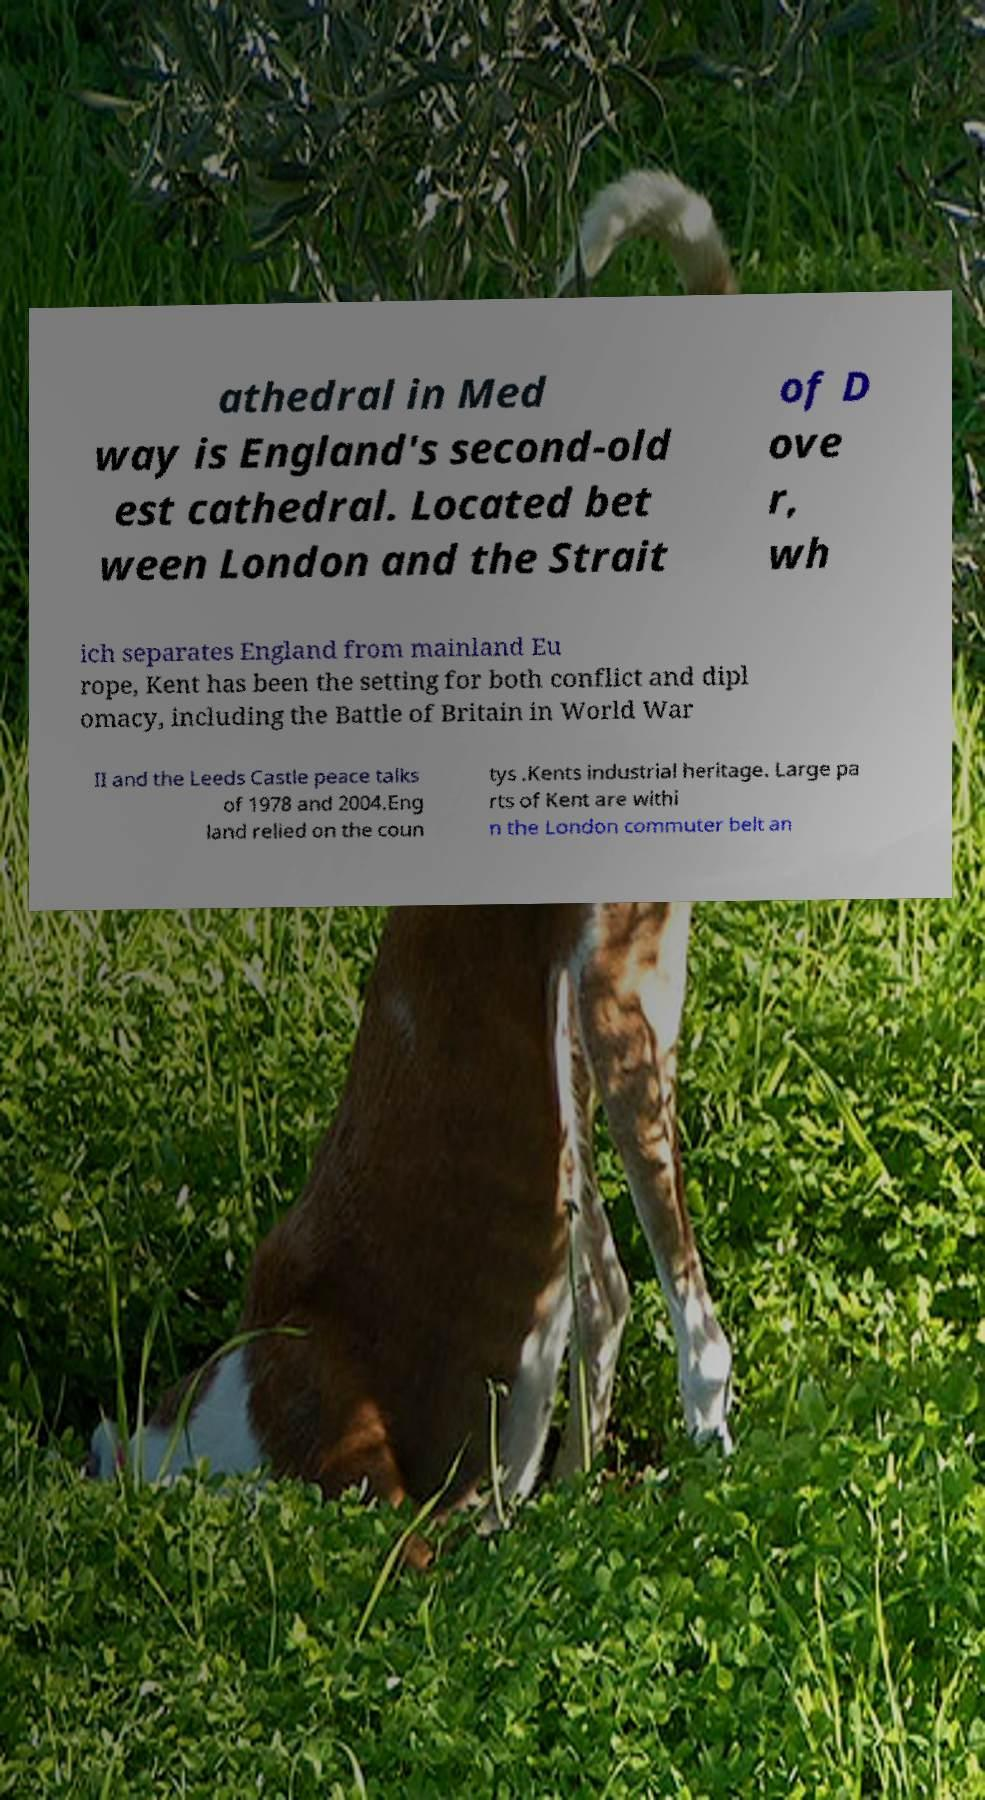Please identify and transcribe the text found in this image. athedral in Med way is England's second-old est cathedral. Located bet ween London and the Strait of D ove r, wh ich separates England from mainland Eu rope, Kent has been the setting for both conflict and dipl omacy, including the Battle of Britain in World War II and the Leeds Castle peace talks of 1978 and 2004.Eng land relied on the coun tys .Kents industrial heritage. Large pa rts of Kent are withi n the London commuter belt an 